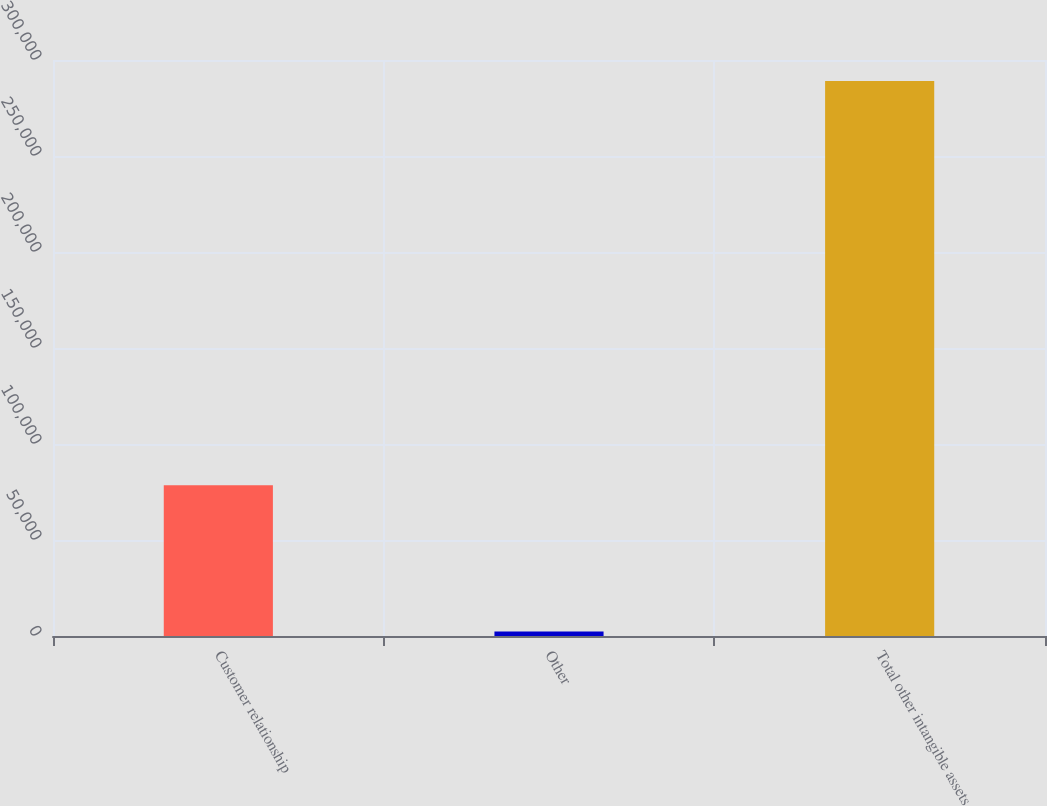Convert chart to OTSL. <chart><loc_0><loc_0><loc_500><loc_500><bar_chart><fcel>Customer relationship<fcel>Other<fcel>Total other intangible assets<nl><fcel>78574<fcel>2329<fcel>289098<nl></chart> 